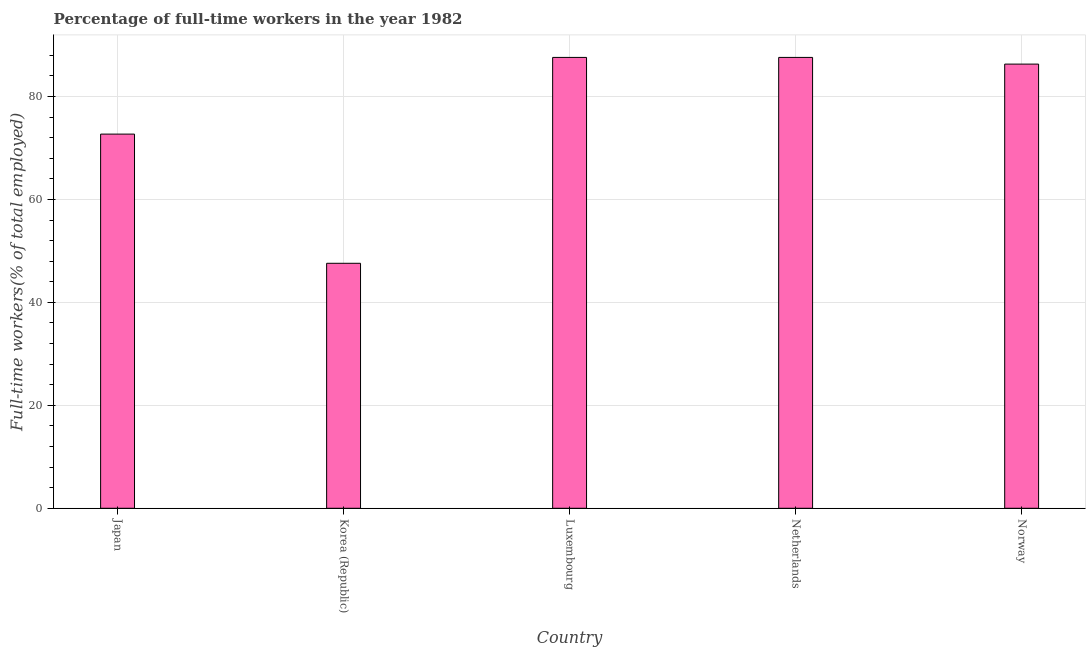Does the graph contain any zero values?
Offer a very short reply. No. Does the graph contain grids?
Your answer should be very brief. Yes. What is the title of the graph?
Offer a terse response. Percentage of full-time workers in the year 1982. What is the label or title of the X-axis?
Your response must be concise. Country. What is the label or title of the Y-axis?
Offer a very short reply. Full-time workers(% of total employed). What is the percentage of full-time workers in Norway?
Give a very brief answer. 86.3. Across all countries, what is the maximum percentage of full-time workers?
Your answer should be compact. 87.6. Across all countries, what is the minimum percentage of full-time workers?
Your answer should be very brief. 47.6. In which country was the percentage of full-time workers maximum?
Provide a short and direct response. Luxembourg. In which country was the percentage of full-time workers minimum?
Keep it short and to the point. Korea (Republic). What is the sum of the percentage of full-time workers?
Your response must be concise. 381.8. What is the difference between the percentage of full-time workers in Luxembourg and Netherlands?
Offer a terse response. 0. What is the average percentage of full-time workers per country?
Your response must be concise. 76.36. What is the median percentage of full-time workers?
Your answer should be compact. 86.3. What is the ratio of the percentage of full-time workers in Korea (Republic) to that in Luxembourg?
Your answer should be very brief. 0.54. Is the percentage of full-time workers in Korea (Republic) less than that in Netherlands?
Your response must be concise. Yes. Is the difference between the percentage of full-time workers in Japan and Netherlands greater than the difference between any two countries?
Ensure brevity in your answer.  No. What is the difference between the highest and the second highest percentage of full-time workers?
Your response must be concise. 0. What is the difference between the highest and the lowest percentage of full-time workers?
Ensure brevity in your answer.  40. How many bars are there?
Offer a very short reply. 5. Are all the bars in the graph horizontal?
Ensure brevity in your answer.  No. How many countries are there in the graph?
Provide a succinct answer. 5. Are the values on the major ticks of Y-axis written in scientific E-notation?
Keep it short and to the point. No. What is the Full-time workers(% of total employed) of Japan?
Provide a short and direct response. 72.7. What is the Full-time workers(% of total employed) of Korea (Republic)?
Offer a very short reply. 47.6. What is the Full-time workers(% of total employed) of Luxembourg?
Provide a succinct answer. 87.6. What is the Full-time workers(% of total employed) in Netherlands?
Provide a short and direct response. 87.6. What is the Full-time workers(% of total employed) of Norway?
Keep it short and to the point. 86.3. What is the difference between the Full-time workers(% of total employed) in Japan and Korea (Republic)?
Make the answer very short. 25.1. What is the difference between the Full-time workers(% of total employed) in Japan and Luxembourg?
Make the answer very short. -14.9. What is the difference between the Full-time workers(% of total employed) in Japan and Netherlands?
Give a very brief answer. -14.9. What is the difference between the Full-time workers(% of total employed) in Japan and Norway?
Your answer should be compact. -13.6. What is the difference between the Full-time workers(% of total employed) in Korea (Republic) and Netherlands?
Ensure brevity in your answer.  -40. What is the difference between the Full-time workers(% of total employed) in Korea (Republic) and Norway?
Ensure brevity in your answer.  -38.7. What is the ratio of the Full-time workers(% of total employed) in Japan to that in Korea (Republic)?
Offer a very short reply. 1.53. What is the ratio of the Full-time workers(% of total employed) in Japan to that in Luxembourg?
Your response must be concise. 0.83. What is the ratio of the Full-time workers(% of total employed) in Japan to that in Netherlands?
Your answer should be very brief. 0.83. What is the ratio of the Full-time workers(% of total employed) in Japan to that in Norway?
Offer a terse response. 0.84. What is the ratio of the Full-time workers(% of total employed) in Korea (Republic) to that in Luxembourg?
Keep it short and to the point. 0.54. What is the ratio of the Full-time workers(% of total employed) in Korea (Republic) to that in Netherlands?
Ensure brevity in your answer.  0.54. What is the ratio of the Full-time workers(% of total employed) in Korea (Republic) to that in Norway?
Your response must be concise. 0.55. What is the ratio of the Full-time workers(% of total employed) in Luxembourg to that in Netherlands?
Provide a short and direct response. 1. What is the ratio of the Full-time workers(% of total employed) in Netherlands to that in Norway?
Ensure brevity in your answer.  1.01. 